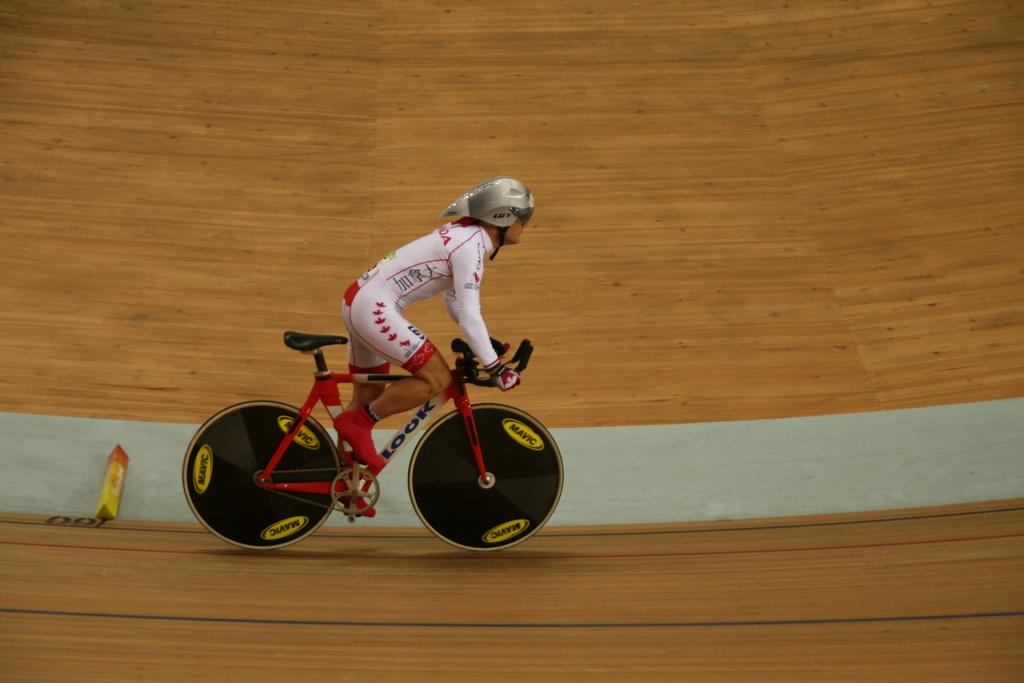Who is present in the image? There is a person in the image. What is the person wearing? The person is wearing a helmet. What activity is the person engaged in? The person is riding a bicycle. Where is the bicycle located? The bicycle is on a path. What type of fang can be seen on the person's bicycle in the image? There are no fangs present on the person's bicycle in the image. 